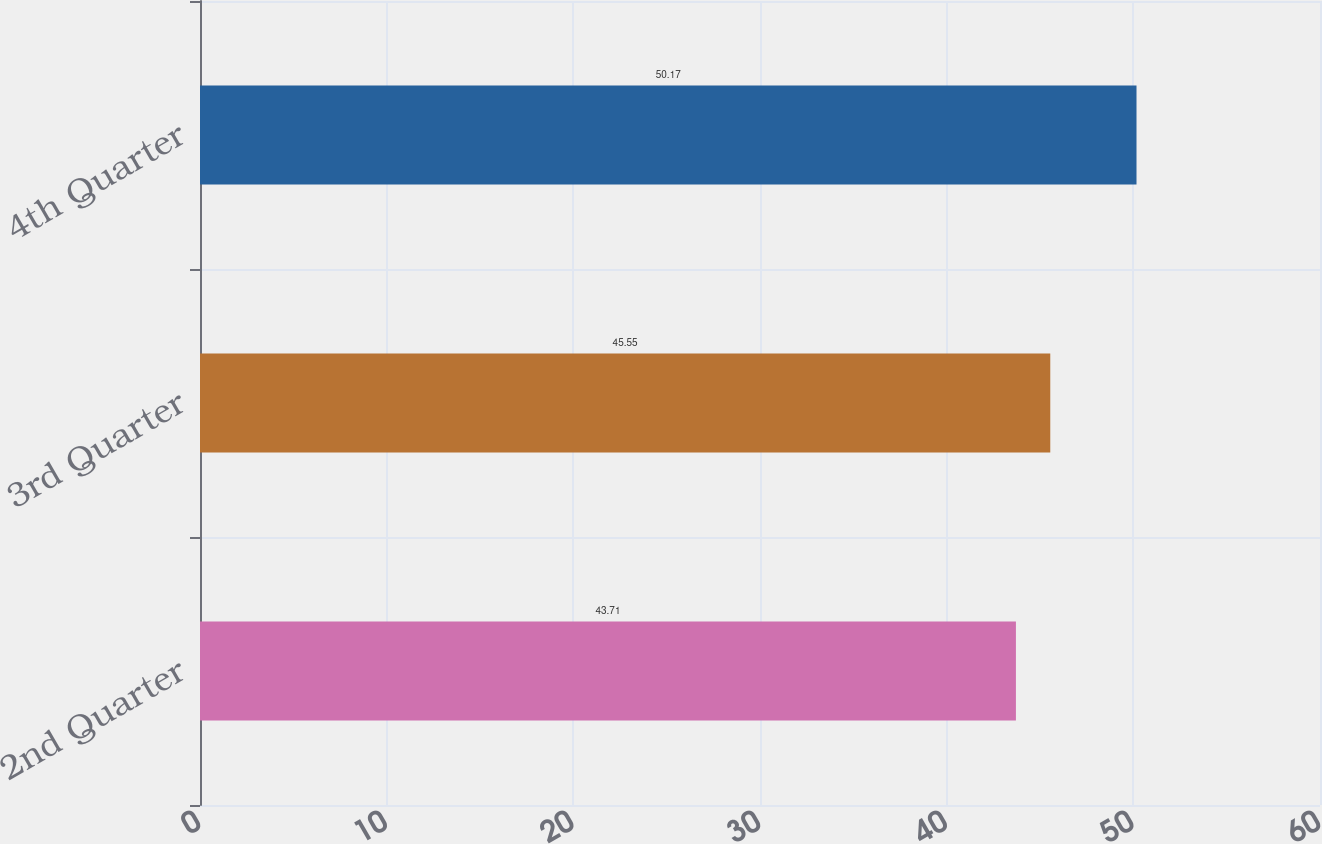<chart> <loc_0><loc_0><loc_500><loc_500><bar_chart><fcel>2nd Quarter<fcel>3rd Quarter<fcel>4th Quarter<nl><fcel>43.71<fcel>45.55<fcel>50.17<nl></chart> 